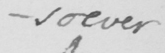Please provide the text content of this handwritten line. -so ever 